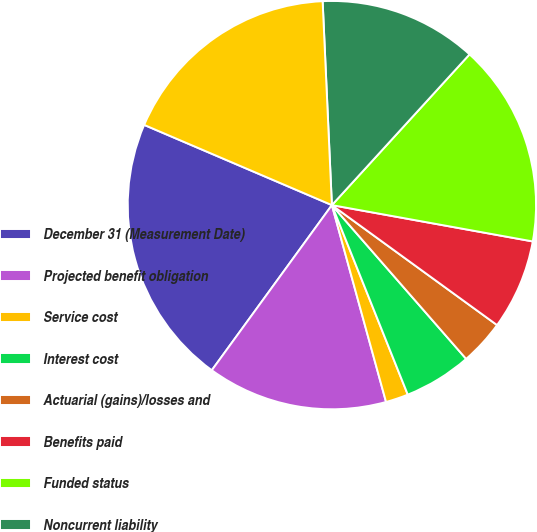Convert chart. <chart><loc_0><loc_0><loc_500><loc_500><pie_chart><fcel>December 31 (Measurement Date)<fcel>Projected benefit obligation<fcel>Service cost<fcel>Interest cost<fcel>Actuarial (gains)/losses and<fcel>Benefits paid<fcel>Funded status<fcel>Noncurrent liability<fcel>Net amount recognized on the<nl><fcel>21.42%<fcel>14.28%<fcel>1.79%<fcel>5.36%<fcel>3.58%<fcel>7.15%<fcel>16.07%<fcel>12.5%<fcel>17.85%<nl></chart> 